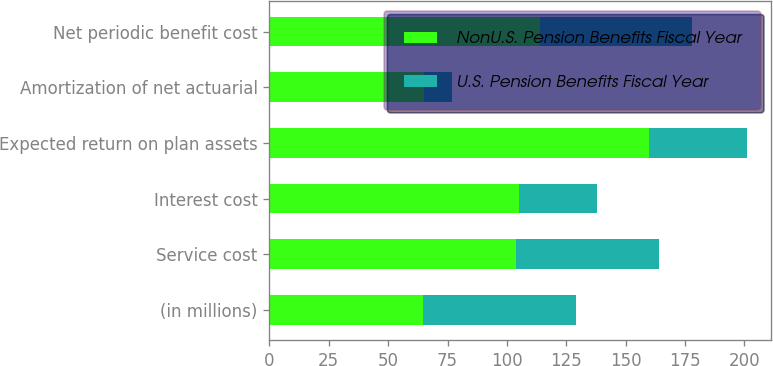Convert chart to OTSL. <chart><loc_0><loc_0><loc_500><loc_500><stacked_bar_chart><ecel><fcel>(in millions)<fcel>Service cost<fcel>Interest cost<fcel>Expected return on plan assets<fcel>Amortization of net actuarial<fcel>Net periodic benefit cost<nl><fcel>NonU.S. Pension Benefits Fiscal Year<fcel>64.5<fcel>104<fcel>105<fcel>160<fcel>65<fcel>114<nl><fcel>U.S. Pension Benefits Fiscal Year<fcel>64.5<fcel>60<fcel>33<fcel>41<fcel>12<fcel>64<nl></chart> 